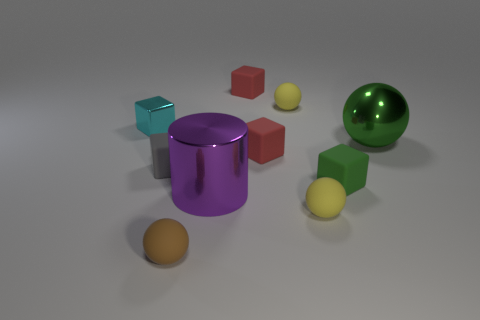What number of other things are made of the same material as the large purple thing?
Your response must be concise. 2. Is the number of small balls in front of the large purple metallic thing greater than the number of metallic cubes that are on the left side of the gray thing?
Provide a short and direct response. Yes. What is the small yellow ball that is behind the small gray object made of?
Your answer should be compact. Rubber. Does the big green shiny thing have the same shape as the brown object?
Ensure brevity in your answer.  Yes. Is there any other thing that has the same color as the metal cylinder?
Make the answer very short. No. There is a small shiny thing that is the same shape as the small gray rubber object; what color is it?
Your response must be concise. Cyan. Are there more tiny red matte cubes that are behind the big green metallic sphere than big brown shiny things?
Provide a succinct answer. Yes. What is the color of the small sphere behind the purple metal cylinder?
Offer a terse response. Yellow. Does the cyan cube have the same size as the green metal thing?
Keep it short and to the point. No. How big is the purple cylinder?
Offer a very short reply. Large. 